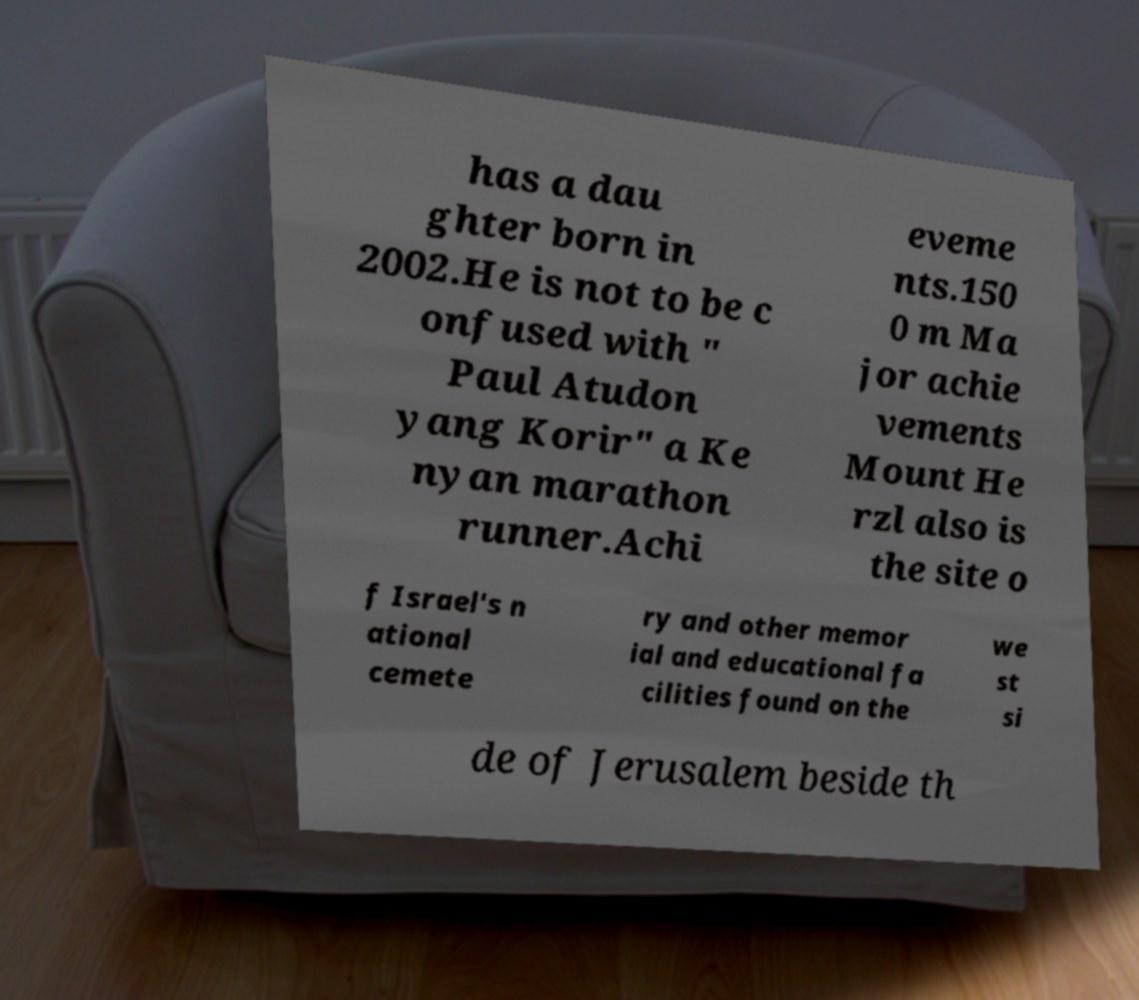Can you read and provide the text displayed in the image?This photo seems to have some interesting text. Can you extract and type it out for me? has a dau ghter born in 2002.He is not to be c onfused with " Paul Atudon yang Korir" a Ke nyan marathon runner.Achi eveme nts.150 0 m Ma jor achie vements Mount He rzl also is the site o f Israel's n ational cemete ry and other memor ial and educational fa cilities found on the we st si de of Jerusalem beside th 